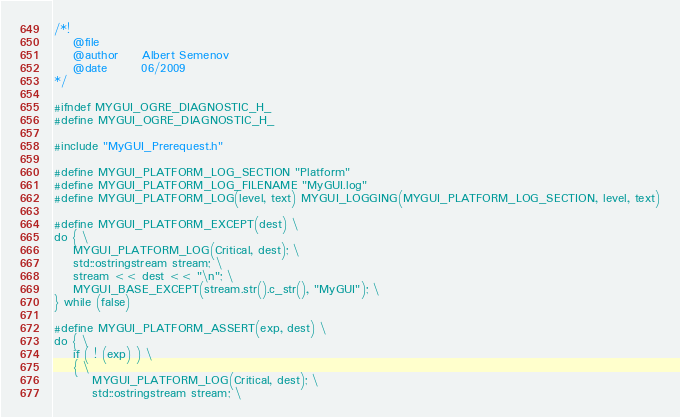Convert code to text. <code><loc_0><loc_0><loc_500><loc_500><_C_>/*!
	@file
	@author		Albert Semenov
	@date		06/2009
*/

#ifndef MYGUI_OGRE_DIAGNOSTIC_H_
#define MYGUI_OGRE_DIAGNOSTIC_H_

#include "MyGUI_Prerequest.h"

#define MYGUI_PLATFORM_LOG_SECTION "Platform"
#define MYGUI_PLATFORM_LOG_FILENAME "MyGUI.log"
#define MYGUI_PLATFORM_LOG(level, text) MYGUI_LOGGING(MYGUI_PLATFORM_LOG_SECTION, level, text)

#define MYGUI_PLATFORM_EXCEPT(dest) \
do { \
	MYGUI_PLATFORM_LOG(Critical, dest); \
	std::ostringstream stream; \
	stream << dest << "\n"; \
	MYGUI_BASE_EXCEPT(stream.str().c_str(), "MyGUI"); \
} while (false)

#define MYGUI_PLATFORM_ASSERT(exp, dest) \
do { \
	if ( ! (exp) ) \
	{ \
		MYGUI_PLATFORM_LOG(Critical, dest); \
		std::ostringstream stream; \</code> 